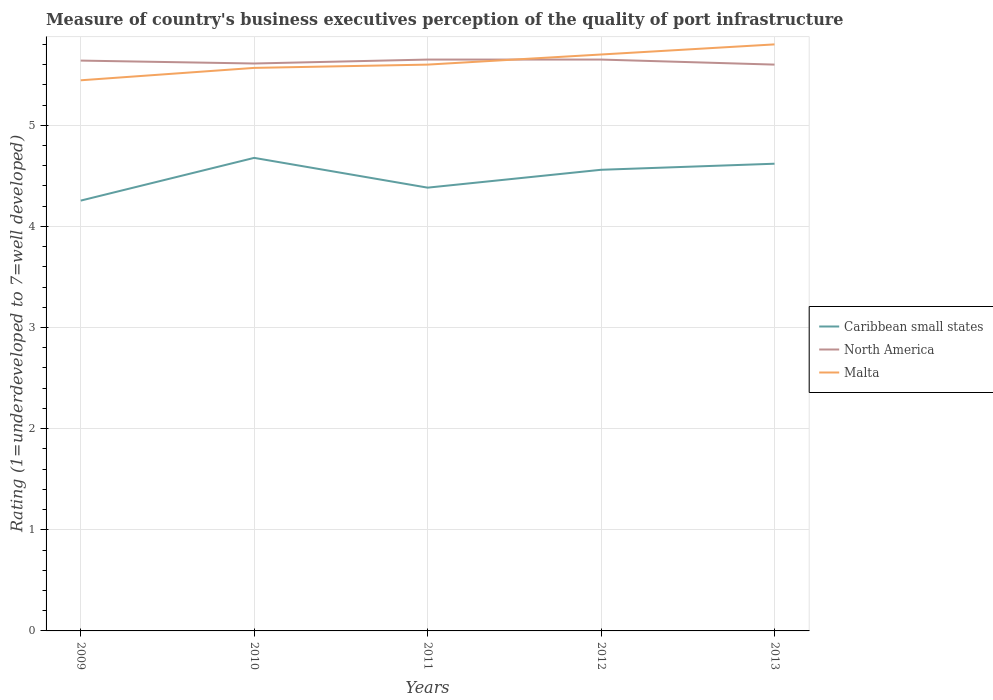Does the line corresponding to North America intersect with the line corresponding to Malta?
Provide a succinct answer. Yes. Across all years, what is the maximum ratings of the quality of port infrastructure in Malta?
Keep it short and to the point. 5.44. In which year was the ratings of the quality of port infrastructure in Caribbean small states maximum?
Ensure brevity in your answer.  2009. What is the total ratings of the quality of port infrastructure in Malta in the graph?
Give a very brief answer. -0.36. What is the difference between the highest and the second highest ratings of the quality of port infrastructure in Malta?
Make the answer very short. 0.36. Does the graph contain any zero values?
Your answer should be compact. No. Does the graph contain grids?
Your response must be concise. Yes. Where does the legend appear in the graph?
Your answer should be compact. Center right. How many legend labels are there?
Offer a very short reply. 3. What is the title of the graph?
Provide a short and direct response. Measure of country's business executives perception of the quality of port infrastructure. What is the label or title of the X-axis?
Make the answer very short. Years. What is the label or title of the Y-axis?
Your answer should be very brief. Rating (1=underdeveloped to 7=well developed). What is the Rating (1=underdeveloped to 7=well developed) of Caribbean small states in 2009?
Offer a very short reply. 4.26. What is the Rating (1=underdeveloped to 7=well developed) in North America in 2009?
Your answer should be compact. 5.64. What is the Rating (1=underdeveloped to 7=well developed) in Malta in 2009?
Provide a succinct answer. 5.44. What is the Rating (1=underdeveloped to 7=well developed) of Caribbean small states in 2010?
Your answer should be compact. 4.68. What is the Rating (1=underdeveloped to 7=well developed) in North America in 2010?
Make the answer very short. 5.61. What is the Rating (1=underdeveloped to 7=well developed) of Malta in 2010?
Ensure brevity in your answer.  5.57. What is the Rating (1=underdeveloped to 7=well developed) of Caribbean small states in 2011?
Offer a very short reply. 4.38. What is the Rating (1=underdeveloped to 7=well developed) in North America in 2011?
Your response must be concise. 5.65. What is the Rating (1=underdeveloped to 7=well developed) of Caribbean small states in 2012?
Your response must be concise. 4.56. What is the Rating (1=underdeveloped to 7=well developed) of North America in 2012?
Ensure brevity in your answer.  5.65. What is the Rating (1=underdeveloped to 7=well developed) of Caribbean small states in 2013?
Your answer should be very brief. 4.62. What is the Rating (1=underdeveloped to 7=well developed) in Malta in 2013?
Make the answer very short. 5.8. Across all years, what is the maximum Rating (1=underdeveloped to 7=well developed) of Caribbean small states?
Provide a succinct answer. 4.68. Across all years, what is the maximum Rating (1=underdeveloped to 7=well developed) of North America?
Offer a very short reply. 5.65. Across all years, what is the maximum Rating (1=underdeveloped to 7=well developed) in Malta?
Provide a succinct answer. 5.8. Across all years, what is the minimum Rating (1=underdeveloped to 7=well developed) of Caribbean small states?
Give a very brief answer. 4.26. Across all years, what is the minimum Rating (1=underdeveloped to 7=well developed) of Malta?
Provide a succinct answer. 5.44. What is the total Rating (1=underdeveloped to 7=well developed) in Caribbean small states in the graph?
Your answer should be very brief. 22.5. What is the total Rating (1=underdeveloped to 7=well developed) of North America in the graph?
Give a very brief answer. 28.15. What is the total Rating (1=underdeveloped to 7=well developed) of Malta in the graph?
Your answer should be very brief. 28.11. What is the difference between the Rating (1=underdeveloped to 7=well developed) in Caribbean small states in 2009 and that in 2010?
Give a very brief answer. -0.42. What is the difference between the Rating (1=underdeveloped to 7=well developed) in North America in 2009 and that in 2010?
Keep it short and to the point. 0.03. What is the difference between the Rating (1=underdeveloped to 7=well developed) in Malta in 2009 and that in 2010?
Keep it short and to the point. -0.12. What is the difference between the Rating (1=underdeveloped to 7=well developed) of Caribbean small states in 2009 and that in 2011?
Keep it short and to the point. -0.13. What is the difference between the Rating (1=underdeveloped to 7=well developed) in North America in 2009 and that in 2011?
Provide a succinct answer. -0.01. What is the difference between the Rating (1=underdeveloped to 7=well developed) of Malta in 2009 and that in 2011?
Provide a succinct answer. -0.15. What is the difference between the Rating (1=underdeveloped to 7=well developed) in Caribbean small states in 2009 and that in 2012?
Provide a succinct answer. -0.3. What is the difference between the Rating (1=underdeveloped to 7=well developed) in North America in 2009 and that in 2012?
Provide a succinct answer. -0.01. What is the difference between the Rating (1=underdeveloped to 7=well developed) in Malta in 2009 and that in 2012?
Provide a succinct answer. -0.26. What is the difference between the Rating (1=underdeveloped to 7=well developed) of Caribbean small states in 2009 and that in 2013?
Provide a short and direct response. -0.36. What is the difference between the Rating (1=underdeveloped to 7=well developed) in North America in 2009 and that in 2013?
Provide a succinct answer. 0.04. What is the difference between the Rating (1=underdeveloped to 7=well developed) in Malta in 2009 and that in 2013?
Your answer should be compact. -0.35. What is the difference between the Rating (1=underdeveloped to 7=well developed) in Caribbean small states in 2010 and that in 2011?
Offer a terse response. 0.29. What is the difference between the Rating (1=underdeveloped to 7=well developed) of North America in 2010 and that in 2011?
Your answer should be very brief. -0.04. What is the difference between the Rating (1=underdeveloped to 7=well developed) of Malta in 2010 and that in 2011?
Keep it short and to the point. -0.03. What is the difference between the Rating (1=underdeveloped to 7=well developed) in Caribbean small states in 2010 and that in 2012?
Offer a very short reply. 0.12. What is the difference between the Rating (1=underdeveloped to 7=well developed) of North America in 2010 and that in 2012?
Offer a very short reply. -0.04. What is the difference between the Rating (1=underdeveloped to 7=well developed) of Malta in 2010 and that in 2012?
Provide a short and direct response. -0.13. What is the difference between the Rating (1=underdeveloped to 7=well developed) in Caribbean small states in 2010 and that in 2013?
Give a very brief answer. 0.06. What is the difference between the Rating (1=underdeveloped to 7=well developed) in North America in 2010 and that in 2013?
Your response must be concise. 0.01. What is the difference between the Rating (1=underdeveloped to 7=well developed) of Malta in 2010 and that in 2013?
Make the answer very short. -0.23. What is the difference between the Rating (1=underdeveloped to 7=well developed) of Caribbean small states in 2011 and that in 2012?
Ensure brevity in your answer.  -0.18. What is the difference between the Rating (1=underdeveloped to 7=well developed) in Caribbean small states in 2011 and that in 2013?
Provide a short and direct response. -0.24. What is the difference between the Rating (1=underdeveloped to 7=well developed) of Caribbean small states in 2012 and that in 2013?
Offer a terse response. -0.06. What is the difference between the Rating (1=underdeveloped to 7=well developed) of North America in 2012 and that in 2013?
Offer a terse response. 0.05. What is the difference between the Rating (1=underdeveloped to 7=well developed) in Malta in 2012 and that in 2013?
Ensure brevity in your answer.  -0.1. What is the difference between the Rating (1=underdeveloped to 7=well developed) in Caribbean small states in 2009 and the Rating (1=underdeveloped to 7=well developed) in North America in 2010?
Provide a succinct answer. -1.36. What is the difference between the Rating (1=underdeveloped to 7=well developed) of Caribbean small states in 2009 and the Rating (1=underdeveloped to 7=well developed) of Malta in 2010?
Make the answer very short. -1.31. What is the difference between the Rating (1=underdeveloped to 7=well developed) in North America in 2009 and the Rating (1=underdeveloped to 7=well developed) in Malta in 2010?
Keep it short and to the point. 0.07. What is the difference between the Rating (1=underdeveloped to 7=well developed) in Caribbean small states in 2009 and the Rating (1=underdeveloped to 7=well developed) in North America in 2011?
Make the answer very short. -1.39. What is the difference between the Rating (1=underdeveloped to 7=well developed) in Caribbean small states in 2009 and the Rating (1=underdeveloped to 7=well developed) in Malta in 2011?
Your response must be concise. -1.34. What is the difference between the Rating (1=underdeveloped to 7=well developed) in North America in 2009 and the Rating (1=underdeveloped to 7=well developed) in Malta in 2011?
Ensure brevity in your answer.  0.04. What is the difference between the Rating (1=underdeveloped to 7=well developed) of Caribbean small states in 2009 and the Rating (1=underdeveloped to 7=well developed) of North America in 2012?
Offer a terse response. -1.39. What is the difference between the Rating (1=underdeveloped to 7=well developed) in Caribbean small states in 2009 and the Rating (1=underdeveloped to 7=well developed) in Malta in 2012?
Offer a very short reply. -1.44. What is the difference between the Rating (1=underdeveloped to 7=well developed) of North America in 2009 and the Rating (1=underdeveloped to 7=well developed) of Malta in 2012?
Your answer should be very brief. -0.06. What is the difference between the Rating (1=underdeveloped to 7=well developed) of Caribbean small states in 2009 and the Rating (1=underdeveloped to 7=well developed) of North America in 2013?
Ensure brevity in your answer.  -1.34. What is the difference between the Rating (1=underdeveloped to 7=well developed) of Caribbean small states in 2009 and the Rating (1=underdeveloped to 7=well developed) of Malta in 2013?
Offer a very short reply. -1.54. What is the difference between the Rating (1=underdeveloped to 7=well developed) in North America in 2009 and the Rating (1=underdeveloped to 7=well developed) in Malta in 2013?
Give a very brief answer. -0.16. What is the difference between the Rating (1=underdeveloped to 7=well developed) of Caribbean small states in 2010 and the Rating (1=underdeveloped to 7=well developed) of North America in 2011?
Keep it short and to the point. -0.97. What is the difference between the Rating (1=underdeveloped to 7=well developed) of Caribbean small states in 2010 and the Rating (1=underdeveloped to 7=well developed) of Malta in 2011?
Give a very brief answer. -0.92. What is the difference between the Rating (1=underdeveloped to 7=well developed) of North America in 2010 and the Rating (1=underdeveloped to 7=well developed) of Malta in 2011?
Offer a terse response. 0.01. What is the difference between the Rating (1=underdeveloped to 7=well developed) of Caribbean small states in 2010 and the Rating (1=underdeveloped to 7=well developed) of North America in 2012?
Provide a succinct answer. -0.97. What is the difference between the Rating (1=underdeveloped to 7=well developed) in Caribbean small states in 2010 and the Rating (1=underdeveloped to 7=well developed) in Malta in 2012?
Provide a short and direct response. -1.02. What is the difference between the Rating (1=underdeveloped to 7=well developed) of North America in 2010 and the Rating (1=underdeveloped to 7=well developed) of Malta in 2012?
Make the answer very short. -0.09. What is the difference between the Rating (1=underdeveloped to 7=well developed) in Caribbean small states in 2010 and the Rating (1=underdeveloped to 7=well developed) in North America in 2013?
Your response must be concise. -0.92. What is the difference between the Rating (1=underdeveloped to 7=well developed) of Caribbean small states in 2010 and the Rating (1=underdeveloped to 7=well developed) of Malta in 2013?
Your response must be concise. -1.12. What is the difference between the Rating (1=underdeveloped to 7=well developed) in North America in 2010 and the Rating (1=underdeveloped to 7=well developed) in Malta in 2013?
Give a very brief answer. -0.19. What is the difference between the Rating (1=underdeveloped to 7=well developed) of Caribbean small states in 2011 and the Rating (1=underdeveloped to 7=well developed) of North America in 2012?
Your answer should be very brief. -1.27. What is the difference between the Rating (1=underdeveloped to 7=well developed) in Caribbean small states in 2011 and the Rating (1=underdeveloped to 7=well developed) in Malta in 2012?
Make the answer very short. -1.32. What is the difference between the Rating (1=underdeveloped to 7=well developed) of North America in 2011 and the Rating (1=underdeveloped to 7=well developed) of Malta in 2012?
Provide a succinct answer. -0.05. What is the difference between the Rating (1=underdeveloped to 7=well developed) in Caribbean small states in 2011 and the Rating (1=underdeveloped to 7=well developed) in North America in 2013?
Offer a terse response. -1.22. What is the difference between the Rating (1=underdeveloped to 7=well developed) of Caribbean small states in 2011 and the Rating (1=underdeveloped to 7=well developed) of Malta in 2013?
Offer a very short reply. -1.42. What is the difference between the Rating (1=underdeveloped to 7=well developed) of Caribbean small states in 2012 and the Rating (1=underdeveloped to 7=well developed) of North America in 2013?
Provide a short and direct response. -1.04. What is the difference between the Rating (1=underdeveloped to 7=well developed) in Caribbean small states in 2012 and the Rating (1=underdeveloped to 7=well developed) in Malta in 2013?
Make the answer very short. -1.24. What is the average Rating (1=underdeveloped to 7=well developed) of Caribbean small states per year?
Offer a terse response. 4.5. What is the average Rating (1=underdeveloped to 7=well developed) in North America per year?
Your answer should be very brief. 5.63. What is the average Rating (1=underdeveloped to 7=well developed) in Malta per year?
Your answer should be compact. 5.62. In the year 2009, what is the difference between the Rating (1=underdeveloped to 7=well developed) of Caribbean small states and Rating (1=underdeveloped to 7=well developed) of North America?
Provide a succinct answer. -1.38. In the year 2009, what is the difference between the Rating (1=underdeveloped to 7=well developed) in Caribbean small states and Rating (1=underdeveloped to 7=well developed) in Malta?
Offer a very short reply. -1.19. In the year 2009, what is the difference between the Rating (1=underdeveloped to 7=well developed) in North America and Rating (1=underdeveloped to 7=well developed) in Malta?
Offer a terse response. 0.19. In the year 2010, what is the difference between the Rating (1=underdeveloped to 7=well developed) in Caribbean small states and Rating (1=underdeveloped to 7=well developed) in North America?
Provide a succinct answer. -0.93. In the year 2010, what is the difference between the Rating (1=underdeveloped to 7=well developed) in Caribbean small states and Rating (1=underdeveloped to 7=well developed) in Malta?
Ensure brevity in your answer.  -0.89. In the year 2010, what is the difference between the Rating (1=underdeveloped to 7=well developed) of North America and Rating (1=underdeveloped to 7=well developed) of Malta?
Ensure brevity in your answer.  0.04. In the year 2011, what is the difference between the Rating (1=underdeveloped to 7=well developed) of Caribbean small states and Rating (1=underdeveloped to 7=well developed) of North America?
Your answer should be very brief. -1.27. In the year 2011, what is the difference between the Rating (1=underdeveloped to 7=well developed) in Caribbean small states and Rating (1=underdeveloped to 7=well developed) in Malta?
Ensure brevity in your answer.  -1.22. In the year 2012, what is the difference between the Rating (1=underdeveloped to 7=well developed) of Caribbean small states and Rating (1=underdeveloped to 7=well developed) of North America?
Give a very brief answer. -1.09. In the year 2012, what is the difference between the Rating (1=underdeveloped to 7=well developed) in Caribbean small states and Rating (1=underdeveloped to 7=well developed) in Malta?
Make the answer very short. -1.14. In the year 2013, what is the difference between the Rating (1=underdeveloped to 7=well developed) of Caribbean small states and Rating (1=underdeveloped to 7=well developed) of North America?
Keep it short and to the point. -0.98. In the year 2013, what is the difference between the Rating (1=underdeveloped to 7=well developed) of Caribbean small states and Rating (1=underdeveloped to 7=well developed) of Malta?
Provide a short and direct response. -1.18. What is the ratio of the Rating (1=underdeveloped to 7=well developed) in Caribbean small states in 2009 to that in 2010?
Your response must be concise. 0.91. What is the ratio of the Rating (1=underdeveloped to 7=well developed) in North America in 2009 to that in 2010?
Ensure brevity in your answer.  1.01. What is the ratio of the Rating (1=underdeveloped to 7=well developed) in Caribbean small states in 2009 to that in 2011?
Your response must be concise. 0.97. What is the ratio of the Rating (1=underdeveloped to 7=well developed) of Malta in 2009 to that in 2011?
Your answer should be very brief. 0.97. What is the ratio of the Rating (1=underdeveloped to 7=well developed) in Caribbean small states in 2009 to that in 2012?
Provide a short and direct response. 0.93. What is the ratio of the Rating (1=underdeveloped to 7=well developed) in Malta in 2009 to that in 2012?
Your response must be concise. 0.96. What is the ratio of the Rating (1=underdeveloped to 7=well developed) in Caribbean small states in 2009 to that in 2013?
Offer a very short reply. 0.92. What is the ratio of the Rating (1=underdeveloped to 7=well developed) of North America in 2009 to that in 2013?
Make the answer very short. 1.01. What is the ratio of the Rating (1=underdeveloped to 7=well developed) in Malta in 2009 to that in 2013?
Offer a terse response. 0.94. What is the ratio of the Rating (1=underdeveloped to 7=well developed) in Caribbean small states in 2010 to that in 2011?
Your answer should be compact. 1.07. What is the ratio of the Rating (1=underdeveloped to 7=well developed) of North America in 2010 to that in 2011?
Keep it short and to the point. 0.99. What is the ratio of the Rating (1=underdeveloped to 7=well developed) of Malta in 2010 to that in 2011?
Provide a short and direct response. 0.99. What is the ratio of the Rating (1=underdeveloped to 7=well developed) in Caribbean small states in 2010 to that in 2012?
Your response must be concise. 1.03. What is the ratio of the Rating (1=underdeveloped to 7=well developed) in North America in 2010 to that in 2012?
Your answer should be compact. 0.99. What is the ratio of the Rating (1=underdeveloped to 7=well developed) in Malta in 2010 to that in 2012?
Make the answer very short. 0.98. What is the ratio of the Rating (1=underdeveloped to 7=well developed) of Caribbean small states in 2010 to that in 2013?
Ensure brevity in your answer.  1.01. What is the ratio of the Rating (1=underdeveloped to 7=well developed) in North America in 2010 to that in 2013?
Offer a terse response. 1. What is the ratio of the Rating (1=underdeveloped to 7=well developed) of Malta in 2010 to that in 2013?
Offer a very short reply. 0.96. What is the ratio of the Rating (1=underdeveloped to 7=well developed) of Caribbean small states in 2011 to that in 2012?
Provide a short and direct response. 0.96. What is the ratio of the Rating (1=underdeveloped to 7=well developed) in Malta in 2011 to that in 2012?
Your answer should be very brief. 0.98. What is the ratio of the Rating (1=underdeveloped to 7=well developed) in Caribbean small states in 2011 to that in 2013?
Make the answer very short. 0.95. What is the ratio of the Rating (1=underdeveloped to 7=well developed) of North America in 2011 to that in 2013?
Give a very brief answer. 1.01. What is the ratio of the Rating (1=underdeveloped to 7=well developed) of Malta in 2011 to that in 2013?
Offer a very short reply. 0.97. What is the ratio of the Rating (1=underdeveloped to 7=well developed) in Caribbean small states in 2012 to that in 2013?
Keep it short and to the point. 0.99. What is the ratio of the Rating (1=underdeveloped to 7=well developed) in North America in 2012 to that in 2013?
Offer a terse response. 1.01. What is the ratio of the Rating (1=underdeveloped to 7=well developed) in Malta in 2012 to that in 2013?
Provide a succinct answer. 0.98. What is the difference between the highest and the second highest Rating (1=underdeveloped to 7=well developed) in Caribbean small states?
Offer a very short reply. 0.06. What is the difference between the highest and the lowest Rating (1=underdeveloped to 7=well developed) of Caribbean small states?
Your answer should be very brief. 0.42. What is the difference between the highest and the lowest Rating (1=underdeveloped to 7=well developed) of North America?
Your answer should be compact. 0.05. What is the difference between the highest and the lowest Rating (1=underdeveloped to 7=well developed) in Malta?
Give a very brief answer. 0.35. 